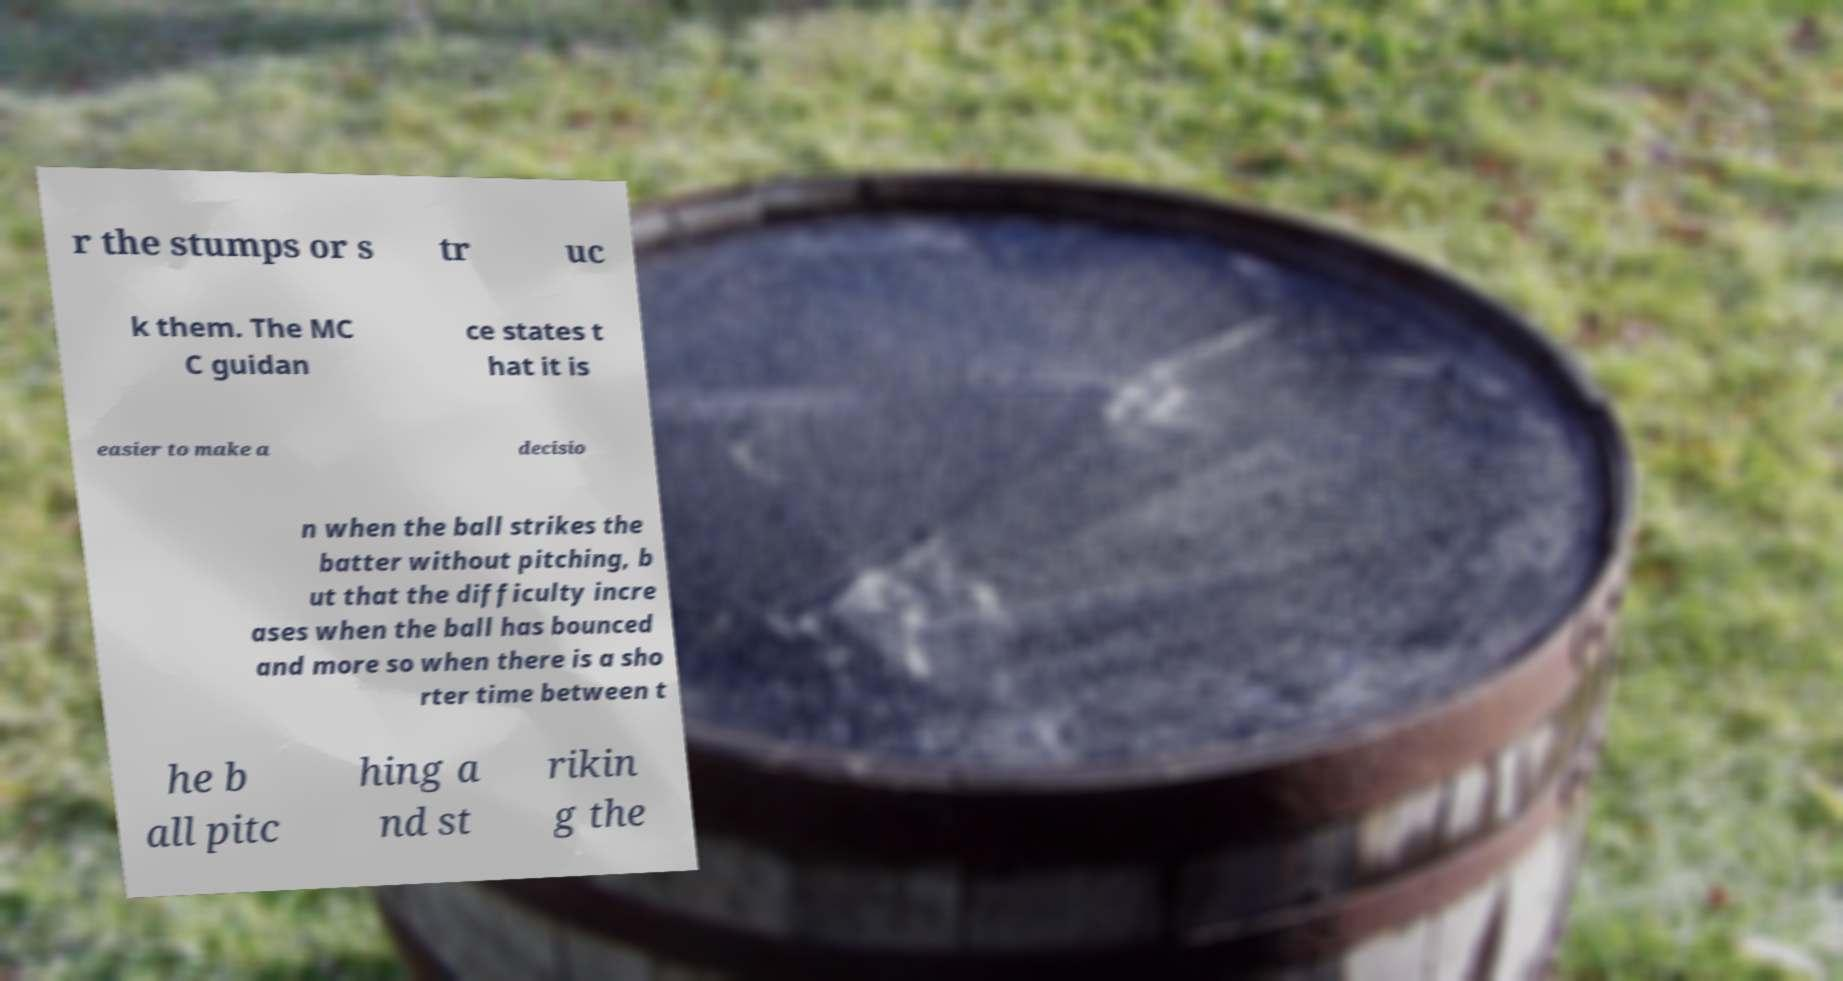Please read and relay the text visible in this image. What does it say? r the stumps or s tr uc k them. The MC C guidan ce states t hat it is easier to make a decisio n when the ball strikes the batter without pitching, b ut that the difficulty incre ases when the ball has bounced and more so when there is a sho rter time between t he b all pitc hing a nd st rikin g the 